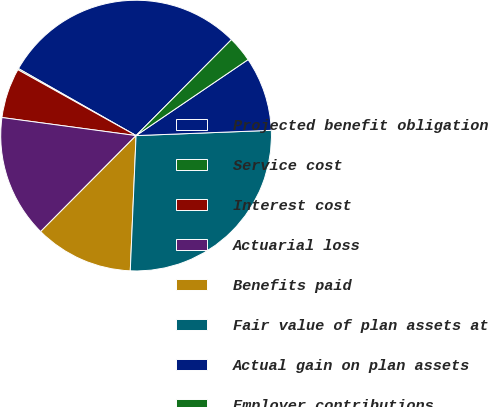Convert chart to OTSL. <chart><loc_0><loc_0><loc_500><loc_500><pie_chart><fcel>Projected benefit obligation<fcel>Service cost<fcel>Interest cost<fcel>Actuarial loss<fcel>Benefits paid<fcel>Fair value of plan assets at<fcel>Actual gain on plan assets<fcel>Employer contributions<nl><fcel>29.21%<fcel>0.15%<fcel>5.96%<fcel>14.68%<fcel>11.77%<fcel>26.3%<fcel>8.87%<fcel>3.06%<nl></chart> 